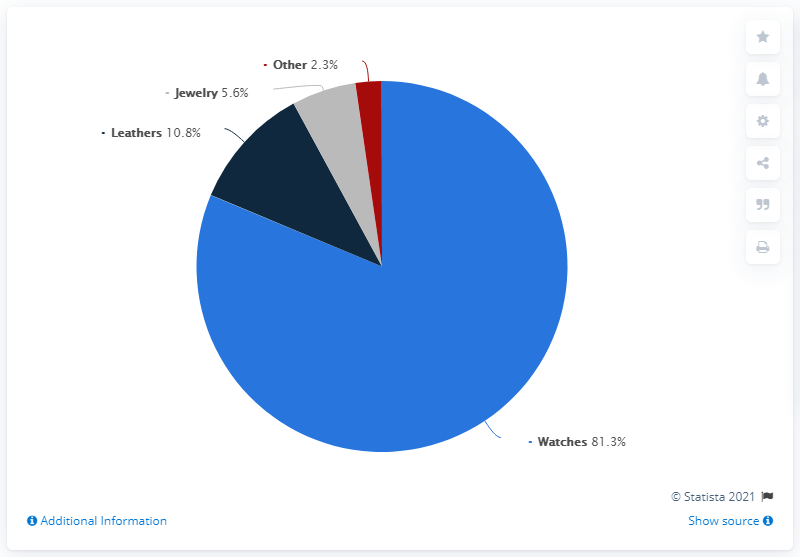Draw attention to some important aspects in this diagram. In 2019, the watches category of Fossil Group accounted for 81.3% of the company's net sales. Laathers is more than Jewelry by a percentage of 5.2%. 